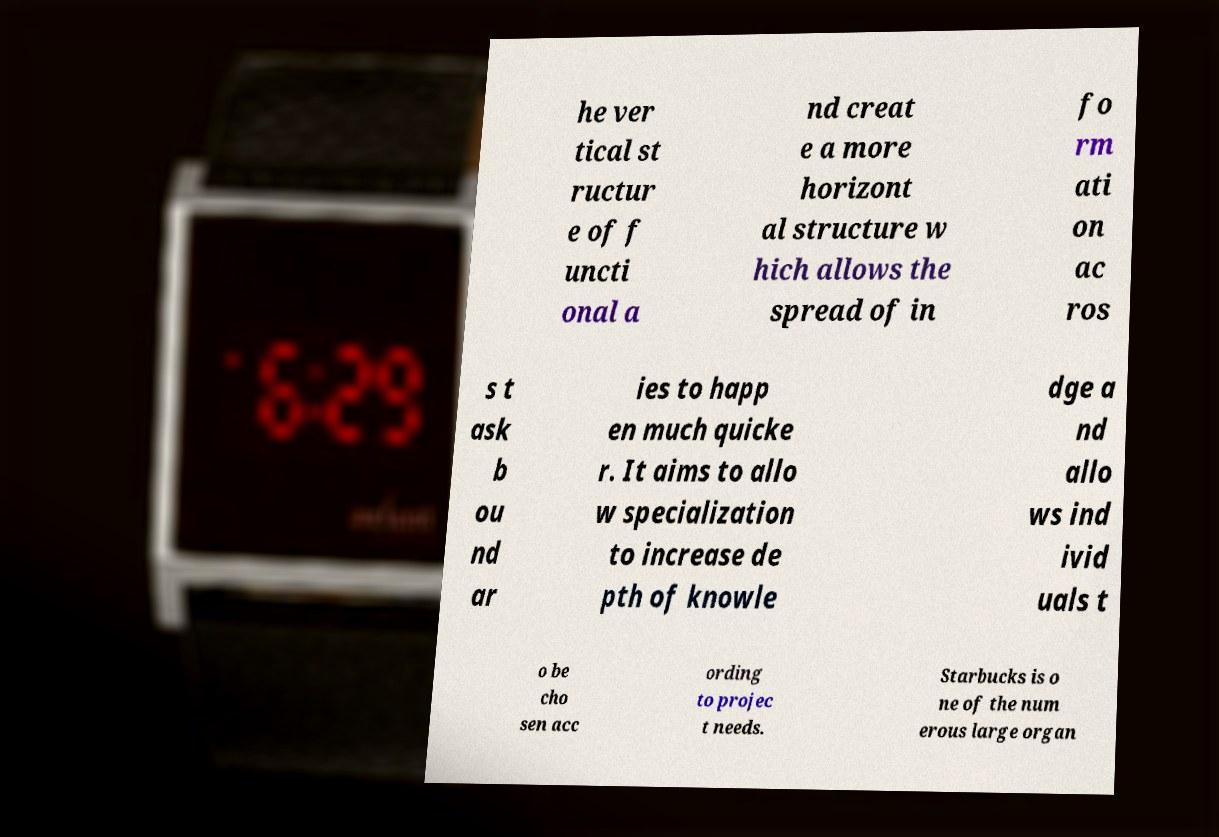For documentation purposes, I need the text within this image transcribed. Could you provide that? he ver tical st ructur e of f uncti onal a nd creat e a more horizont al structure w hich allows the spread of in fo rm ati on ac ros s t ask b ou nd ar ies to happ en much quicke r. It aims to allo w specialization to increase de pth of knowle dge a nd allo ws ind ivid uals t o be cho sen acc ording to projec t needs. Starbucks is o ne of the num erous large organ 